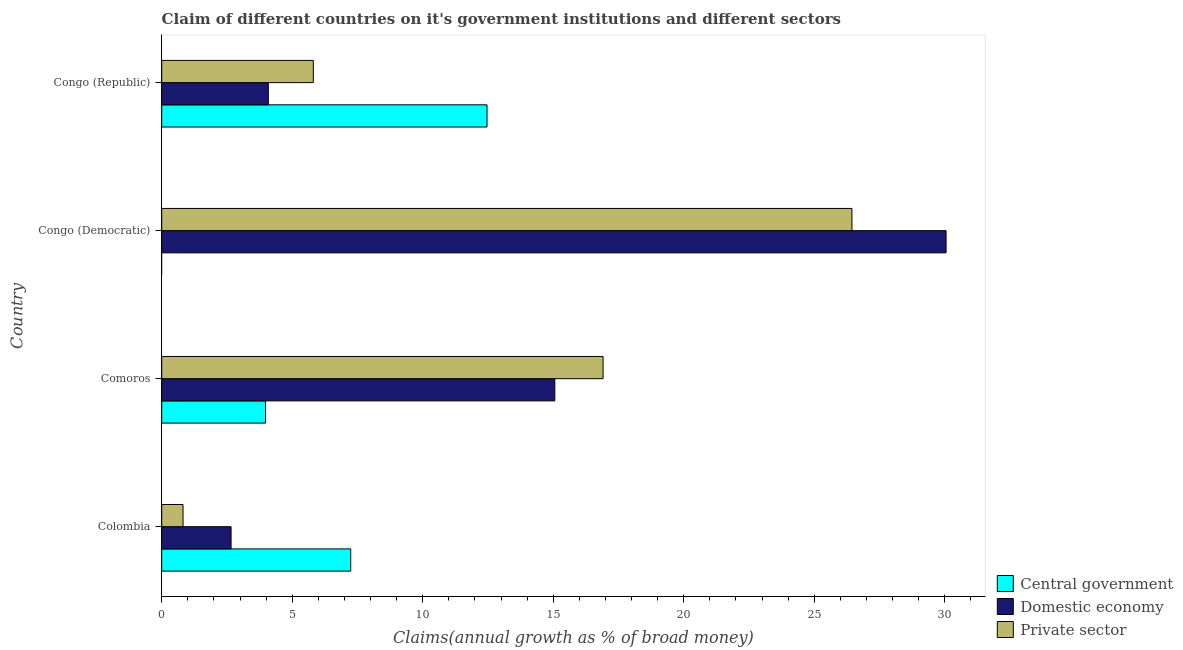How many different coloured bars are there?
Your answer should be compact. 3. How many groups of bars are there?
Keep it short and to the point. 4. How many bars are there on the 1st tick from the top?
Ensure brevity in your answer.  3. How many bars are there on the 2nd tick from the bottom?
Your answer should be very brief. 3. What is the label of the 3rd group of bars from the top?
Ensure brevity in your answer.  Comoros. In how many cases, is the number of bars for a given country not equal to the number of legend labels?
Provide a succinct answer. 1. What is the percentage of claim on the domestic economy in Comoros?
Offer a very short reply. 15.06. Across all countries, what is the maximum percentage of claim on the private sector?
Your answer should be compact. 26.44. Across all countries, what is the minimum percentage of claim on the domestic economy?
Provide a succinct answer. 2.66. In which country was the percentage of claim on the domestic economy maximum?
Give a very brief answer. Congo (Democratic). What is the total percentage of claim on the private sector in the graph?
Make the answer very short. 49.98. What is the difference between the percentage of claim on the private sector in Colombia and that in Congo (Republic)?
Make the answer very short. -4.99. What is the difference between the percentage of claim on the domestic economy in Congo (Democratic) and the percentage of claim on the central government in Congo (Republic)?
Provide a succinct answer. 17.59. What is the average percentage of claim on the domestic economy per country?
Ensure brevity in your answer.  12.96. What is the difference between the percentage of claim on the domestic economy and percentage of claim on the private sector in Colombia?
Your answer should be very brief. 1.84. In how many countries, is the percentage of claim on the domestic economy greater than 17 %?
Give a very brief answer. 1. What is the ratio of the percentage of claim on the central government in Comoros to that in Congo (Republic)?
Your response must be concise. 0.32. Is the difference between the percentage of claim on the private sector in Comoros and Congo (Republic) greater than the difference between the percentage of claim on the central government in Comoros and Congo (Republic)?
Offer a very short reply. Yes. What is the difference between the highest and the second highest percentage of claim on the private sector?
Your response must be concise. 9.53. What is the difference between the highest and the lowest percentage of claim on the central government?
Offer a terse response. 12.46. In how many countries, is the percentage of claim on the private sector greater than the average percentage of claim on the private sector taken over all countries?
Give a very brief answer. 2. Are all the bars in the graph horizontal?
Your response must be concise. Yes. How many countries are there in the graph?
Your response must be concise. 4. What is the difference between two consecutive major ticks on the X-axis?
Offer a very short reply. 5. Does the graph contain any zero values?
Offer a terse response. Yes. Where does the legend appear in the graph?
Make the answer very short. Bottom right. How are the legend labels stacked?
Offer a very short reply. Vertical. What is the title of the graph?
Provide a short and direct response. Claim of different countries on it's government institutions and different sectors. What is the label or title of the X-axis?
Offer a very short reply. Claims(annual growth as % of broad money). What is the Claims(annual growth as % of broad money) of Central government in Colombia?
Offer a terse response. 7.24. What is the Claims(annual growth as % of broad money) of Domestic economy in Colombia?
Make the answer very short. 2.66. What is the Claims(annual growth as % of broad money) of Private sector in Colombia?
Your response must be concise. 0.82. What is the Claims(annual growth as % of broad money) in Central government in Comoros?
Ensure brevity in your answer.  3.98. What is the Claims(annual growth as % of broad money) of Domestic economy in Comoros?
Offer a terse response. 15.06. What is the Claims(annual growth as % of broad money) in Private sector in Comoros?
Provide a succinct answer. 16.91. What is the Claims(annual growth as % of broad money) in Central government in Congo (Democratic)?
Ensure brevity in your answer.  0. What is the Claims(annual growth as % of broad money) of Domestic economy in Congo (Democratic)?
Make the answer very short. 30.05. What is the Claims(annual growth as % of broad money) of Private sector in Congo (Democratic)?
Provide a succinct answer. 26.44. What is the Claims(annual growth as % of broad money) in Central government in Congo (Republic)?
Your answer should be very brief. 12.46. What is the Claims(annual growth as % of broad money) in Domestic economy in Congo (Republic)?
Keep it short and to the point. 4.08. What is the Claims(annual growth as % of broad money) of Private sector in Congo (Republic)?
Offer a very short reply. 5.81. Across all countries, what is the maximum Claims(annual growth as % of broad money) in Central government?
Your response must be concise. 12.46. Across all countries, what is the maximum Claims(annual growth as % of broad money) of Domestic economy?
Provide a succinct answer. 30.05. Across all countries, what is the maximum Claims(annual growth as % of broad money) in Private sector?
Offer a terse response. 26.44. Across all countries, what is the minimum Claims(annual growth as % of broad money) of Domestic economy?
Offer a terse response. 2.66. Across all countries, what is the minimum Claims(annual growth as % of broad money) in Private sector?
Keep it short and to the point. 0.82. What is the total Claims(annual growth as % of broad money) of Central government in the graph?
Provide a short and direct response. 23.68. What is the total Claims(annual growth as % of broad money) in Domestic economy in the graph?
Provide a short and direct response. 51.85. What is the total Claims(annual growth as % of broad money) of Private sector in the graph?
Offer a very short reply. 49.98. What is the difference between the Claims(annual growth as % of broad money) of Central government in Colombia and that in Comoros?
Make the answer very short. 3.26. What is the difference between the Claims(annual growth as % of broad money) in Domestic economy in Colombia and that in Comoros?
Provide a short and direct response. -12.4. What is the difference between the Claims(annual growth as % of broad money) of Private sector in Colombia and that in Comoros?
Provide a succinct answer. -16.09. What is the difference between the Claims(annual growth as % of broad money) of Domestic economy in Colombia and that in Congo (Democratic)?
Ensure brevity in your answer.  -27.39. What is the difference between the Claims(annual growth as % of broad money) of Private sector in Colombia and that in Congo (Democratic)?
Provide a short and direct response. -25.62. What is the difference between the Claims(annual growth as % of broad money) of Central government in Colombia and that in Congo (Republic)?
Ensure brevity in your answer.  -5.22. What is the difference between the Claims(annual growth as % of broad money) of Domestic economy in Colombia and that in Congo (Republic)?
Keep it short and to the point. -1.43. What is the difference between the Claims(annual growth as % of broad money) of Private sector in Colombia and that in Congo (Republic)?
Offer a terse response. -4.99. What is the difference between the Claims(annual growth as % of broad money) of Domestic economy in Comoros and that in Congo (Democratic)?
Offer a very short reply. -14.99. What is the difference between the Claims(annual growth as % of broad money) in Private sector in Comoros and that in Congo (Democratic)?
Keep it short and to the point. -9.53. What is the difference between the Claims(annual growth as % of broad money) of Central government in Comoros and that in Congo (Republic)?
Offer a very short reply. -8.49. What is the difference between the Claims(annual growth as % of broad money) in Domestic economy in Comoros and that in Congo (Republic)?
Provide a short and direct response. 10.98. What is the difference between the Claims(annual growth as % of broad money) of Private sector in Comoros and that in Congo (Republic)?
Provide a short and direct response. 11.1. What is the difference between the Claims(annual growth as % of broad money) of Domestic economy in Congo (Democratic) and that in Congo (Republic)?
Ensure brevity in your answer.  25.96. What is the difference between the Claims(annual growth as % of broad money) in Private sector in Congo (Democratic) and that in Congo (Republic)?
Provide a short and direct response. 20.63. What is the difference between the Claims(annual growth as % of broad money) in Central government in Colombia and the Claims(annual growth as % of broad money) in Domestic economy in Comoros?
Make the answer very short. -7.82. What is the difference between the Claims(annual growth as % of broad money) of Central government in Colombia and the Claims(annual growth as % of broad money) of Private sector in Comoros?
Offer a terse response. -9.67. What is the difference between the Claims(annual growth as % of broad money) of Domestic economy in Colombia and the Claims(annual growth as % of broad money) of Private sector in Comoros?
Keep it short and to the point. -14.25. What is the difference between the Claims(annual growth as % of broad money) in Central government in Colombia and the Claims(annual growth as % of broad money) in Domestic economy in Congo (Democratic)?
Provide a succinct answer. -22.81. What is the difference between the Claims(annual growth as % of broad money) of Central government in Colombia and the Claims(annual growth as % of broad money) of Private sector in Congo (Democratic)?
Your response must be concise. -19.2. What is the difference between the Claims(annual growth as % of broad money) in Domestic economy in Colombia and the Claims(annual growth as % of broad money) in Private sector in Congo (Democratic)?
Your answer should be compact. -23.78. What is the difference between the Claims(annual growth as % of broad money) of Central government in Colombia and the Claims(annual growth as % of broad money) of Domestic economy in Congo (Republic)?
Your response must be concise. 3.16. What is the difference between the Claims(annual growth as % of broad money) of Central government in Colombia and the Claims(annual growth as % of broad money) of Private sector in Congo (Republic)?
Provide a short and direct response. 1.43. What is the difference between the Claims(annual growth as % of broad money) in Domestic economy in Colombia and the Claims(annual growth as % of broad money) in Private sector in Congo (Republic)?
Your response must be concise. -3.15. What is the difference between the Claims(annual growth as % of broad money) of Central government in Comoros and the Claims(annual growth as % of broad money) of Domestic economy in Congo (Democratic)?
Keep it short and to the point. -26.07. What is the difference between the Claims(annual growth as % of broad money) in Central government in Comoros and the Claims(annual growth as % of broad money) in Private sector in Congo (Democratic)?
Your answer should be compact. -22.47. What is the difference between the Claims(annual growth as % of broad money) of Domestic economy in Comoros and the Claims(annual growth as % of broad money) of Private sector in Congo (Democratic)?
Ensure brevity in your answer.  -11.38. What is the difference between the Claims(annual growth as % of broad money) in Central government in Comoros and the Claims(annual growth as % of broad money) in Domestic economy in Congo (Republic)?
Your response must be concise. -0.11. What is the difference between the Claims(annual growth as % of broad money) in Central government in Comoros and the Claims(annual growth as % of broad money) in Private sector in Congo (Republic)?
Provide a short and direct response. -1.83. What is the difference between the Claims(annual growth as % of broad money) of Domestic economy in Comoros and the Claims(annual growth as % of broad money) of Private sector in Congo (Republic)?
Provide a short and direct response. 9.25. What is the difference between the Claims(annual growth as % of broad money) in Domestic economy in Congo (Democratic) and the Claims(annual growth as % of broad money) in Private sector in Congo (Republic)?
Your response must be concise. 24.24. What is the average Claims(annual growth as % of broad money) of Central government per country?
Your answer should be compact. 5.92. What is the average Claims(annual growth as % of broad money) in Domestic economy per country?
Offer a very short reply. 12.96. What is the average Claims(annual growth as % of broad money) in Private sector per country?
Give a very brief answer. 12.49. What is the difference between the Claims(annual growth as % of broad money) of Central government and Claims(annual growth as % of broad money) of Domestic economy in Colombia?
Your answer should be very brief. 4.58. What is the difference between the Claims(annual growth as % of broad money) of Central government and Claims(annual growth as % of broad money) of Private sector in Colombia?
Provide a succinct answer. 6.42. What is the difference between the Claims(annual growth as % of broad money) in Domestic economy and Claims(annual growth as % of broad money) in Private sector in Colombia?
Keep it short and to the point. 1.84. What is the difference between the Claims(annual growth as % of broad money) of Central government and Claims(annual growth as % of broad money) of Domestic economy in Comoros?
Make the answer very short. -11.08. What is the difference between the Claims(annual growth as % of broad money) in Central government and Claims(annual growth as % of broad money) in Private sector in Comoros?
Your response must be concise. -12.93. What is the difference between the Claims(annual growth as % of broad money) in Domestic economy and Claims(annual growth as % of broad money) in Private sector in Comoros?
Keep it short and to the point. -1.85. What is the difference between the Claims(annual growth as % of broad money) of Domestic economy and Claims(annual growth as % of broad money) of Private sector in Congo (Democratic)?
Provide a succinct answer. 3.61. What is the difference between the Claims(annual growth as % of broad money) of Central government and Claims(annual growth as % of broad money) of Domestic economy in Congo (Republic)?
Offer a terse response. 8.38. What is the difference between the Claims(annual growth as % of broad money) in Central government and Claims(annual growth as % of broad money) in Private sector in Congo (Republic)?
Your response must be concise. 6.65. What is the difference between the Claims(annual growth as % of broad money) of Domestic economy and Claims(annual growth as % of broad money) of Private sector in Congo (Republic)?
Your answer should be compact. -1.72. What is the ratio of the Claims(annual growth as % of broad money) of Central government in Colombia to that in Comoros?
Give a very brief answer. 1.82. What is the ratio of the Claims(annual growth as % of broad money) in Domestic economy in Colombia to that in Comoros?
Ensure brevity in your answer.  0.18. What is the ratio of the Claims(annual growth as % of broad money) of Private sector in Colombia to that in Comoros?
Ensure brevity in your answer.  0.05. What is the ratio of the Claims(annual growth as % of broad money) of Domestic economy in Colombia to that in Congo (Democratic)?
Offer a very short reply. 0.09. What is the ratio of the Claims(annual growth as % of broad money) in Private sector in Colombia to that in Congo (Democratic)?
Your answer should be very brief. 0.03. What is the ratio of the Claims(annual growth as % of broad money) in Central government in Colombia to that in Congo (Republic)?
Offer a terse response. 0.58. What is the ratio of the Claims(annual growth as % of broad money) in Domestic economy in Colombia to that in Congo (Republic)?
Ensure brevity in your answer.  0.65. What is the ratio of the Claims(annual growth as % of broad money) of Private sector in Colombia to that in Congo (Republic)?
Offer a very short reply. 0.14. What is the ratio of the Claims(annual growth as % of broad money) in Domestic economy in Comoros to that in Congo (Democratic)?
Provide a succinct answer. 0.5. What is the ratio of the Claims(annual growth as % of broad money) of Private sector in Comoros to that in Congo (Democratic)?
Offer a terse response. 0.64. What is the ratio of the Claims(annual growth as % of broad money) of Central government in Comoros to that in Congo (Republic)?
Your response must be concise. 0.32. What is the ratio of the Claims(annual growth as % of broad money) of Domestic economy in Comoros to that in Congo (Republic)?
Offer a terse response. 3.69. What is the ratio of the Claims(annual growth as % of broad money) in Private sector in Comoros to that in Congo (Republic)?
Keep it short and to the point. 2.91. What is the ratio of the Claims(annual growth as % of broad money) in Domestic economy in Congo (Democratic) to that in Congo (Republic)?
Provide a short and direct response. 7.36. What is the ratio of the Claims(annual growth as % of broad money) in Private sector in Congo (Democratic) to that in Congo (Republic)?
Offer a terse response. 4.55. What is the difference between the highest and the second highest Claims(annual growth as % of broad money) in Central government?
Keep it short and to the point. 5.22. What is the difference between the highest and the second highest Claims(annual growth as % of broad money) in Domestic economy?
Your response must be concise. 14.99. What is the difference between the highest and the second highest Claims(annual growth as % of broad money) in Private sector?
Offer a very short reply. 9.53. What is the difference between the highest and the lowest Claims(annual growth as % of broad money) of Central government?
Your answer should be compact. 12.46. What is the difference between the highest and the lowest Claims(annual growth as % of broad money) of Domestic economy?
Ensure brevity in your answer.  27.39. What is the difference between the highest and the lowest Claims(annual growth as % of broad money) in Private sector?
Ensure brevity in your answer.  25.62. 